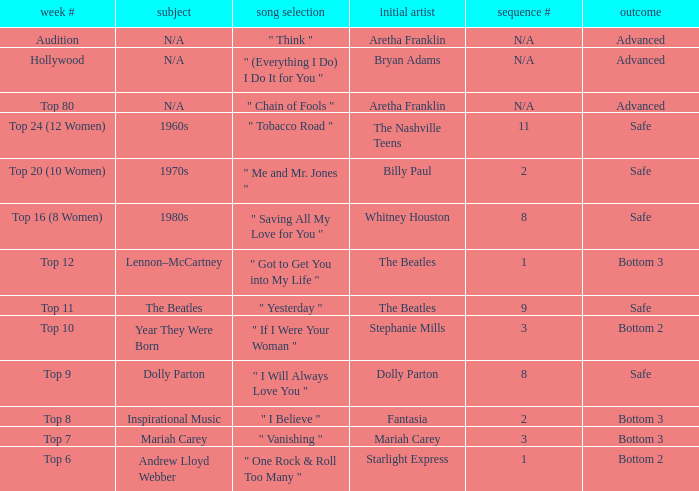Name the song choice when week number is hollywood " (Everything I Do) I Do It for You ". 